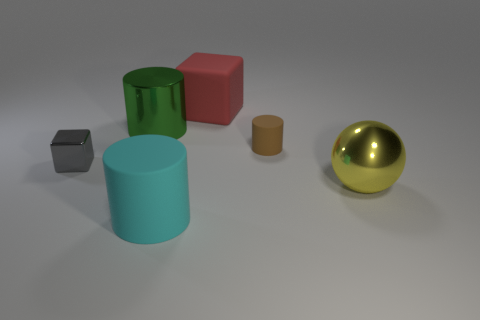There is a green metal thing; how many metal objects are to the left of it?
Your answer should be very brief. 1. How big is the matte block?
Your answer should be very brief. Large. What color is the cylinder that is the same material as the cyan object?
Ensure brevity in your answer.  Brown. How many yellow balls have the same size as the yellow metal thing?
Keep it short and to the point. 0. Is the object in front of the yellow ball made of the same material as the large block?
Give a very brief answer. Yes. Are there fewer small objects on the left side of the tiny shiny cube than small metallic objects?
Make the answer very short. Yes. What shape is the big thing behind the green cylinder?
Provide a succinct answer. Cube. What shape is the gray shiny object that is the same size as the brown cylinder?
Ensure brevity in your answer.  Cube. Are there any brown matte things of the same shape as the tiny gray metal thing?
Your response must be concise. No. There is a large metal object in front of the big green object; is its shape the same as the tiny thing that is in front of the brown rubber thing?
Ensure brevity in your answer.  No. 